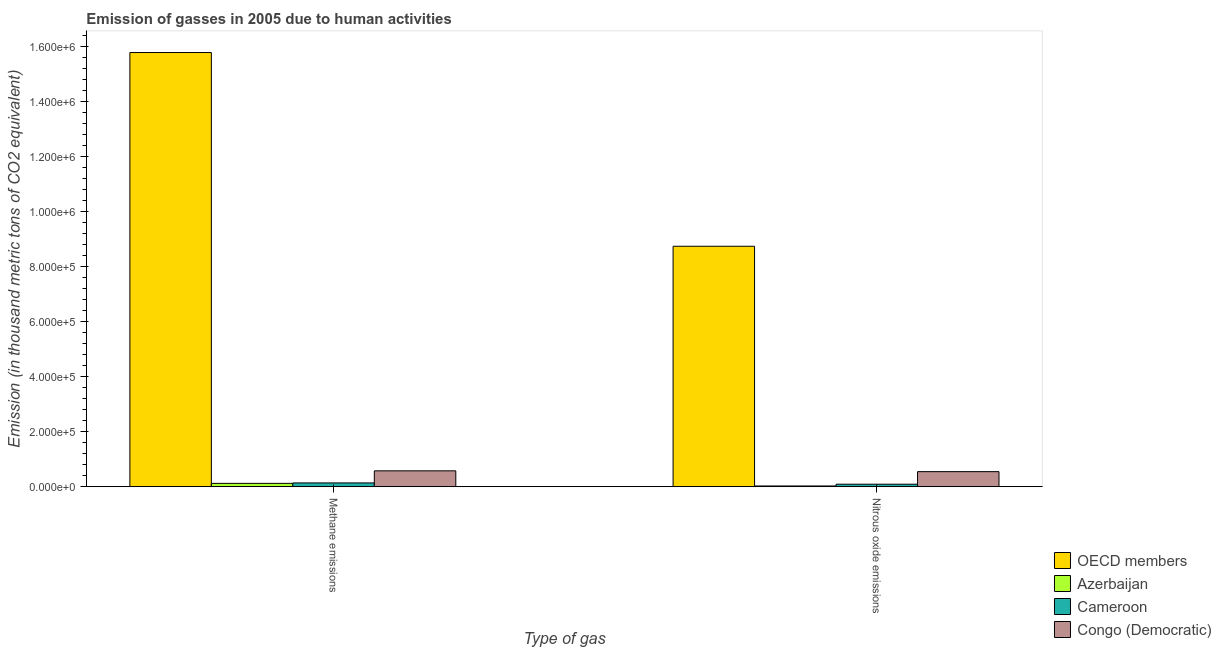How many different coloured bars are there?
Offer a terse response. 4. How many bars are there on the 2nd tick from the left?
Give a very brief answer. 4. How many bars are there on the 1st tick from the right?
Your answer should be compact. 4. What is the label of the 1st group of bars from the left?
Make the answer very short. Methane emissions. What is the amount of methane emissions in Congo (Democratic)?
Your response must be concise. 5.77e+04. Across all countries, what is the maximum amount of nitrous oxide emissions?
Offer a terse response. 8.75e+05. Across all countries, what is the minimum amount of nitrous oxide emissions?
Offer a terse response. 2599.6. In which country was the amount of methane emissions minimum?
Your answer should be very brief. Azerbaijan. What is the total amount of nitrous oxide emissions in the graph?
Your response must be concise. 9.41e+05. What is the difference between the amount of methane emissions in Azerbaijan and that in OECD members?
Give a very brief answer. -1.57e+06. What is the difference between the amount of methane emissions in OECD members and the amount of nitrous oxide emissions in Cameroon?
Your answer should be compact. 1.57e+06. What is the average amount of nitrous oxide emissions per country?
Provide a succinct answer. 2.35e+05. What is the difference between the amount of methane emissions and amount of nitrous oxide emissions in OECD members?
Ensure brevity in your answer.  7.05e+05. What is the ratio of the amount of nitrous oxide emissions in OECD members to that in Azerbaijan?
Offer a terse response. 336.44. What does the 2nd bar from the left in Methane emissions represents?
Give a very brief answer. Azerbaijan. What does the 4th bar from the right in Nitrous oxide emissions represents?
Make the answer very short. OECD members. How many bars are there?
Make the answer very short. 8. Are all the bars in the graph horizontal?
Your response must be concise. No. How many countries are there in the graph?
Offer a terse response. 4. Does the graph contain grids?
Offer a terse response. No. What is the title of the graph?
Make the answer very short. Emission of gasses in 2005 due to human activities. What is the label or title of the X-axis?
Ensure brevity in your answer.  Type of gas. What is the label or title of the Y-axis?
Ensure brevity in your answer.  Emission (in thousand metric tons of CO2 equivalent). What is the Emission (in thousand metric tons of CO2 equivalent) in OECD members in Methane emissions?
Offer a very short reply. 1.58e+06. What is the Emission (in thousand metric tons of CO2 equivalent) in Azerbaijan in Methane emissions?
Your answer should be very brief. 1.21e+04. What is the Emission (in thousand metric tons of CO2 equivalent) of Cameroon in Methane emissions?
Make the answer very short. 1.37e+04. What is the Emission (in thousand metric tons of CO2 equivalent) in Congo (Democratic) in Methane emissions?
Keep it short and to the point. 5.77e+04. What is the Emission (in thousand metric tons of CO2 equivalent) in OECD members in Nitrous oxide emissions?
Ensure brevity in your answer.  8.75e+05. What is the Emission (in thousand metric tons of CO2 equivalent) in Azerbaijan in Nitrous oxide emissions?
Provide a succinct answer. 2599.6. What is the Emission (in thousand metric tons of CO2 equivalent) of Cameroon in Nitrous oxide emissions?
Give a very brief answer. 9027.2. What is the Emission (in thousand metric tons of CO2 equivalent) in Congo (Democratic) in Nitrous oxide emissions?
Ensure brevity in your answer.  5.47e+04. Across all Type of gas, what is the maximum Emission (in thousand metric tons of CO2 equivalent) in OECD members?
Your answer should be very brief. 1.58e+06. Across all Type of gas, what is the maximum Emission (in thousand metric tons of CO2 equivalent) of Azerbaijan?
Provide a succinct answer. 1.21e+04. Across all Type of gas, what is the maximum Emission (in thousand metric tons of CO2 equivalent) in Cameroon?
Your response must be concise. 1.37e+04. Across all Type of gas, what is the maximum Emission (in thousand metric tons of CO2 equivalent) in Congo (Democratic)?
Give a very brief answer. 5.77e+04. Across all Type of gas, what is the minimum Emission (in thousand metric tons of CO2 equivalent) of OECD members?
Give a very brief answer. 8.75e+05. Across all Type of gas, what is the minimum Emission (in thousand metric tons of CO2 equivalent) of Azerbaijan?
Ensure brevity in your answer.  2599.6. Across all Type of gas, what is the minimum Emission (in thousand metric tons of CO2 equivalent) in Cameroon?
Your response must be concise. 9027.2. Across all Type of gas, what is the minimum Emission (in thousand metric tons of CO2 equivalent) in Congo (Democratic)?
Provide a short and direct response. 5.47e+04. What is the total Emission (in thousand metric tons of CO2 equivalent) in OECD members in the graph?
Offer a terse response. 2.45e+06. What is the total Emission (in thousand metric tons of CO2 equivalent) in Azerbaijan in the graph?
Offer a terse response. 1.47e+04. What is the total Emission (in thousand metric tons of CO2 equivalent) of Cameroon in the graph?
Your answer should be very brief. 2.27e+04. What is the total Emission (in thousand metric tons of CO2 equivalent) of Congo (Democratic) in the graph?
Your response must be concise. 1.12e+05. What is the difference between the Emission (in thousand metric tons of CO2 equivalent) in OECD members in Methane emissions and that in Nitrous oxide emissions?
Provide a succinct answer. 7.05e+05. What is the difference between the Emission (in thousand metric tons of CO2 equivalent) of Azerbaijan in Methane emissions and that in Nitrous oxide emissions?
Keep it short and to the point. 9496.7. What is the difference between the Emission (in thousand metric tons of CO2 equivalent) in Cameroon in Methane emissions and that in Nitrous oxide emissions?
Your response must be concise. 4672.4. What is the difference between the Emission (in thousand metric tons of CO2 equivalent) in Congo (Democratic) in Methane emissions and that in Nitrous oxide emissions?
Your answer should be compact. 2983.2. What is the difference between the Emission (in thousand metric tons of CO2 equivalent) in OECD members in Methane emissions and the Emission (in thousand metric tons of CO2 equivalent) in Azerbaijan in Nitrous oxide emissions?
Offer a terse response. 1.58e+06. What is the difference between the Emission (in thousand metric tons of CO2 equivalent) in OECD members in Methane emissions and the Emission (in thousand metric tons of CO2 equivalent) in Cameroon in Nitrous oxide emissions?
Ensure brevity in your answer.  1.57e+06. What is the difference between the Emission (in thousand metric tons of CO2 equivalent) in OECD members in Methane emissions and the Emission (in thousand metric tons of CO2 equivalent) in Congo (Democratic) in Nitrous oxide emissions?
Make the answer very short. 1.52e+06. What is the difference between the Emission (in thousand metric tons of CO2 equivalent) in Azerbaijan in Methane emissions and the Emission (in thousand metric tons of CO2 equivalent) in Cameroon in Nitrous oxide emissions?
Your answer should be very brief. 3069.1. What is the difference between the Emission (in thousand metric tons of CO2 equivalent) in Azerbaijan in Methane emissions and the Emission (in thousand metric tons of CO2 equivalent) in Congo (Democratic) in Nitrous oxide emissions?
Keep it short and to the point. -4.26e+04. What is the difference between the Emission (in thousand metric tons of CO2 equivalent) of Cameroon in Methane emissions and the Emission (in thousand metric tons of CO2 equivalent) of Congo (Democratic) in Nitrous oxide emissions?
Make the answer very short. -4.10e+04. What is the average Emission (in thousand metric tons of CO2 equivalent) of OECD members per Type of gas?
Provide a succinct answer. 1.23e+06. What is the average Emission (in thousand metric tons of CO2 equivalent) of Azerbaijan per Type of gas?
Keep it short and to the point. 7347.95. What is the average Emission (in thousand metric tons of CO2 equivalent) in Cameroon per Type of gas?
Provide a short and direct response. 1.14e+04. What is the average Emission (in thousand metric tons of CO2 equivalent) in Congo (Democratic) per Type of gas?
Offer a very short reply. 5.62e+04. What is the difference between the Emission (in thousand metric tons of CO2 equivalent) of OECD members and Emission (in thousand metric tons of CO2 equivalent) of Azerbaijan in Methane emissions?
Offer a terse response. 1.57e+06. What is the difference between the Emission (in thousand metric tons of CO2 equivalent) of OECD members and Emission (in thousand metric tons of CO2 equivalent) of Cameroon in Methane emissions?
Your answer should be very brief. 1.57e+06. What is the difference between the Emission (in thousand metric tons of CO2 equivalent) of OECD members and Emission (in thousand metric tons of CO2 equivalent) of Congo (Democratic) in Methane emissions?
Make the answer very short. 1.52e+06. What is the difference between the Emission (in thousand metric tons of CO2 equivalent) in Azerbaijan and Emission (in thousand metric tons of CO2 equivalent) in Cameroon in Methane emissions?
Ensure brevity in your answer.  -1603.3. What is the difference between the Emission (in thousand metric tons of CO2 equivalent) in Azerbaijan and Emission (in thousand metric tons of CO2 equivalent) in Congo (Democratic) in Methane emissions?
Keep it short and to the point. -4.56e+04. What is the difference between the Emission (in thousand metric tons of CO2 equivalent) in Cameroon and Emission (in thousand metric tons of CO2 equivalent) in Congo (Democratic) in Methane emissions?
Keep it short and to the point. -4.40e+04. What is the difference between the Emission (in thousand metric tons of CO2 equivalent) in OECD members and Emission (in thousand metric tons of CO2 equivalent) in Azerbaijan in Nitrous oxide emissions?
Provide a succinct answer. 8.72e+05. What is the difference between the Emission (in thousand metric tons of CO2 equivalent) in OECD members and Emission (in thousand metric tons of CO2 equivalent) in Cameroon in Nitrous oxide emissions?
Provide a succinct answer. 8.66e+05. What is the difference between the Emission (in thousand metric tons of CO2 equivalent) of OECD members and Emission (in thousand metric tons of CO2 equivalent) of Congo (Democratic) in Nitrous oxide emissions?
Provide a short and direct response. 8.20e+05. What is the difference between the Emission (in thousand metric tons of CO2 equivalent) in Azerbaijan and Emission (in thousand metric tons of CO2 equivalent) in Cameroon in Nitrous oxide emissions?
Offer a very short reply. -6427.6. What is the difference between the Emission (in thousand metric tons of CO2 equivalent) in Azerbaijan and Emission (in thousand metric tons of CO2 equivalent) in Congo (Democratic) in Nitrous oxide emissions?
Offer a very short reply. -5.21e+04. What is the difference between the Emission (in thousand metric tons of CO2 equivalent) of Cameroon and Emission (in thousand metric tons of CO2 equivalent) of Congo (Democratic) in Nitrous oxide emissions?
Provide a succinct answer. -4.57e+04. What is the ratio of the Emission (in thousand metric tons of CO2 equivalent) of OECD members in Methane emissions to that in Nitrous oxide emissions?
Make the answer very short. 1.81. What is the ratio of the Emission (in thousand metric tons of CO2 equivalent) in Azerbaijan in Methane emissions to that in Nitrous oxide emissions?
Ensure brevity in your answer.  4.65. What is the ratio of the Emission (in thousand metric tons of CO2 equivalent) of Cameroon in Methane emissions to that in Nitrous oxide emissions?
Give a very brief answer. 1.52. What is the ratio of the Emission (in thousand metric tons of CO2 equivalent) in Congo (Democratic) in Methane emissions to that in Nitrous oxide emissions?
Ensure brevity in your answer.  1.05. What is the difference between the highest and the second highest Emission (in thousand metric tons of CO2 equivalent) in OECD members?
Your response must be concise. 7.05e+05. What is the difference between the highest and the second highest Emission (in thousand metric tons of CO2 equivalent) of Azerbaijan?
Your response must be concise. 9496.7. What is the difference between the highest and the second highest Emission (in thousand metric tons of CO2 equivalent) in Cameroon?
Make the answer very short. 4672.4. What is the difference between the highest and the second highest Emission (in thousand metric tons of CO2 equivalent) of Congo (Democratic)?
Offer a very short reply. 2983.2. What is the difference between the highest and the lowest Emission (in thousand metric tons of CO2 equivalent) in OECD members?
Your response must be concise. 7.05e+05. What is the difference between the highest and the lowest Emission (in thousand metric tons of CO2 equivalent) in Azerbaijan?
Ensure brevity in your answer.  9496.7. What is the difference between the highest and the lowest Emission (in thousand metric tons of CO2 equivalent) in Cameroon?
Provide a succinct answer. 4672.4. What is the difference between the highest and the lowest Emission (in thousand metric tons of CO2 equivalent) in Congo (Democratic)?
Provide a succinct answer. 2983.2. 